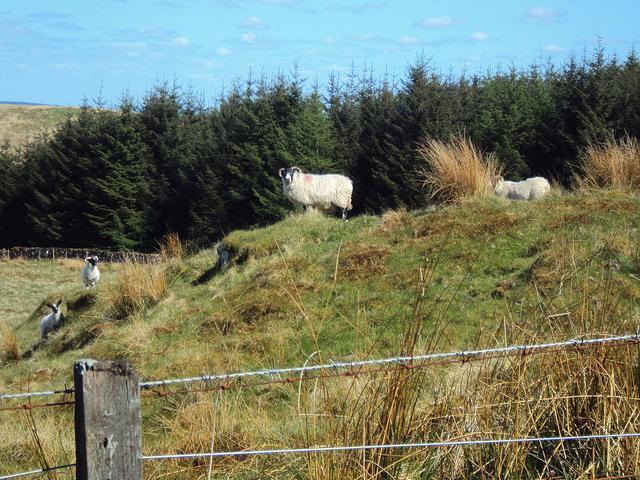How many sheep are there?
Give a very brief answer. 1. 